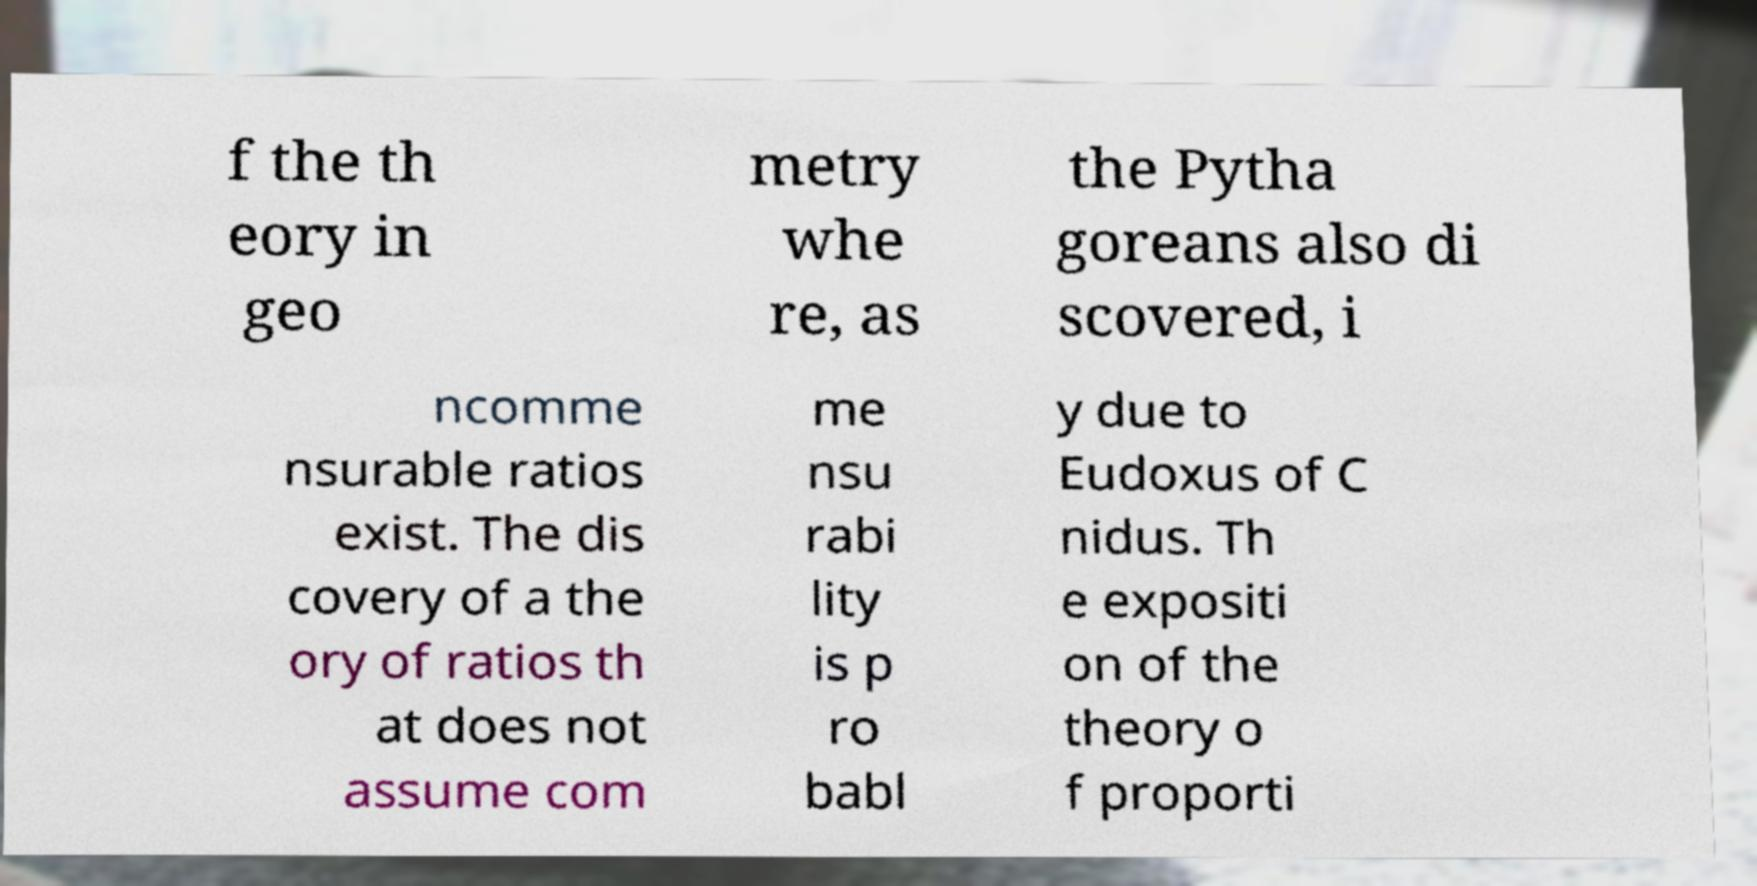I need the written content from this picture converted into text. Can you do that? f the th eory in geo metry whe re, as the Pytha goreans also di scovered, i ncomme nsurable ratios exist. The dis covery of a the ory of ratios th at does not assume com me nsu rabi lity is p ro babl y due to Eudoxus of C nidus. Th e expositi on of the theory o f proporti 